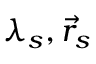<formula> <loc_0><loc_0><loc_500><loc_500>\lambda _ { s } , \vec { r } _ { s }</formula> 